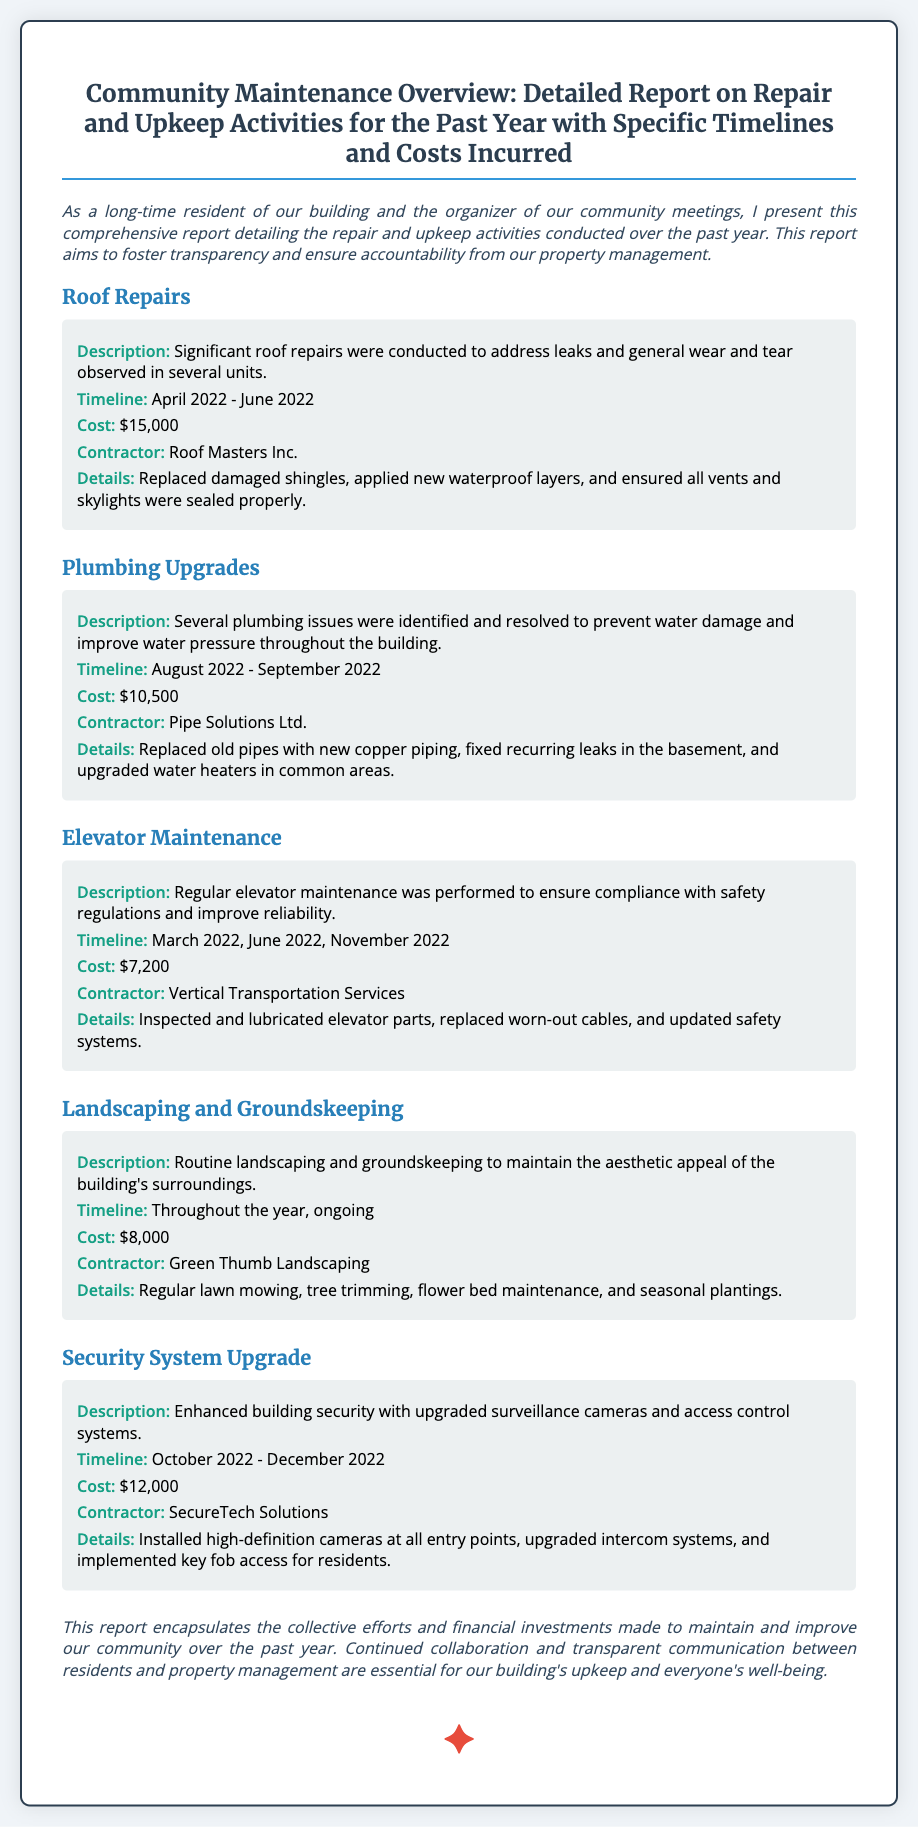what was the cost of roof repairs? The cost of roof repairs is listed in the document as $15,000.
Answer: $15,000 who was the contractor for plumbing upgrades? The document states that Pipe Solutions Ltd. was the contractor for plumbing upgrades.
Answer: Pipe Solutions Ltd when did the elevator maintenance take place? The elevator maintenance occurred in March 2022, June 2022, and November 2022 according to the report.
Answer: March 2022, June 2022, November 2022 what was the total cost of landscaping and groundskeeping? The total cost for landscaping and groundskeeping throughout the year is noted as $8,000.
Answer: $8,000 what security enhancement was made in 2022? The document mentions that upgraded surveillance cameras and access control systems were implemented for security enhancement.
Answer: upgraded surveillance cameras and access control systems which contractor handled the security system upgrade? The contractor for the security system upgrade is listed as SecureTech Solutions in the report.
Answer: SecureTech Solutions what was the timeline for roof repairs? The timeline for roof repairs is stated as April 2022 to June 2022 in the document.
Answer: April 2022 - June 2022 how often was landscaping performed? The report indicates that landscaping was conducted throughout the year, ongoing.
Answer: ongoing what was the primary issue addressed by plumbing upgrades? The primary issue addressed by plumbing upgrades was to prevent water damage and improve water pressure.
Answer: prevent water damage and improve water pressure 